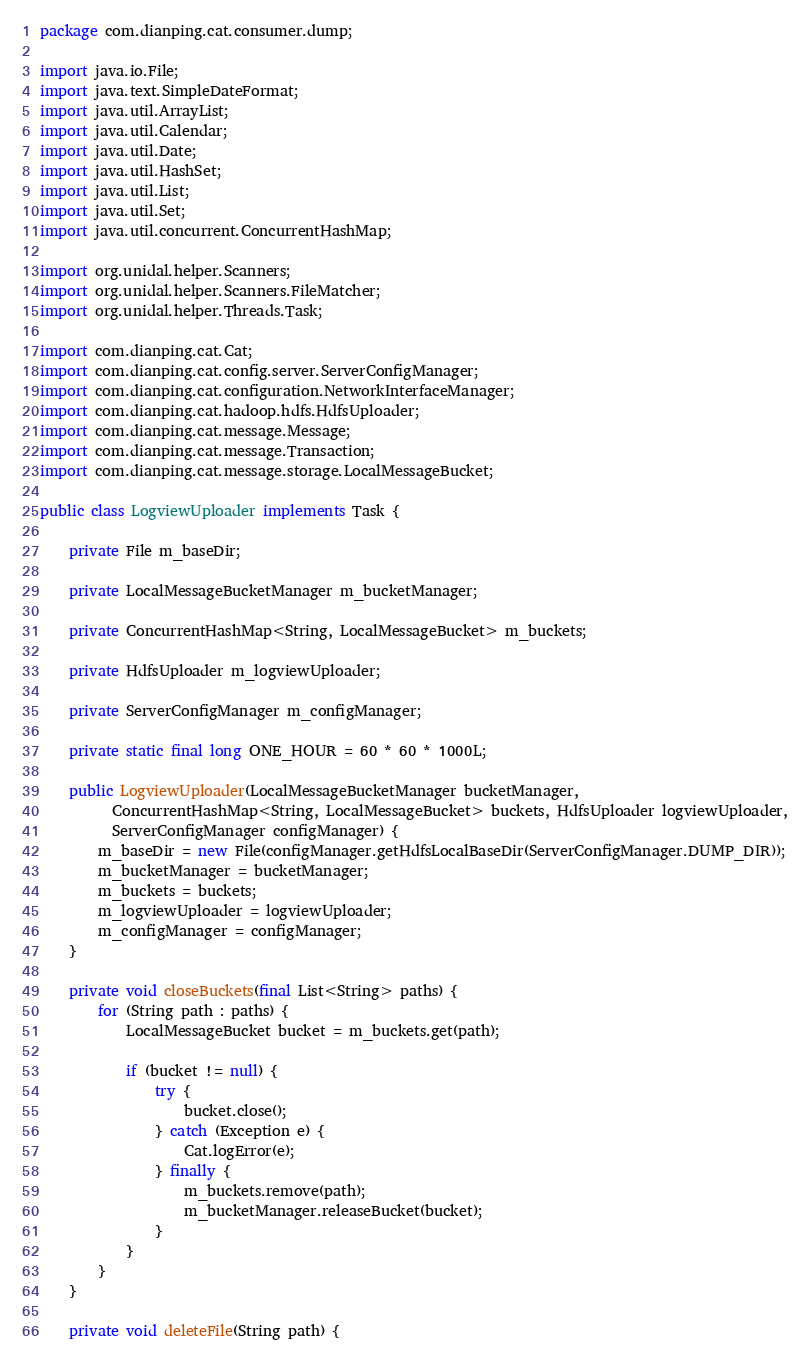<code> <loc_0><loc_0><loc_500><loc_500><_Java_>package com.dianping.cat.consumer.dump;

import java.io.File;
import java.text.SimpleDateFormat;
import java.util.ArrayList;
import java.util.Calendar;
import java.util.Date;
import java.util.HashSet;
import java.util.List;
import java.util.Set;
import java.util.concurrent.ConcurrentHashMap;

import org.unidal.helper.Scanners;
import org.unidal.helper.Scanners.FileMatcher;
import org.unidal.helper.Threads.Task;

import com.dianping.cat.Cat;
import com.dianping.cat.config.server.ServerConfigManager;
import com.dianping.cat.configuration.NetworkInterfaceManager;
import com.dianping.cat.hadoop.hdfs.HdfsUploader;
import com.dianping.cat.message.Message;
import com.dianping.cat.message.Transaction;
import com.dianping.cat.message.storage.LocalMessageBucket;

public class LogviewUploader implements Task {

	private File m_baseDir;

	private LocalMessageBucketManager m_bucketManager;

	private ConcurrentHashMap<String, LocalMessageBucket> m_buckets;

	private HdfsUploader m_logviewUploader;

	private ServerConfigManager m_configManager;

	private static final long ONE_HOUR = 60 * 60 * 1000L;

	public LogviewUploader(LocalMessageBucketManager bucketManager,
	      ConcurrentHashMap<String, LocalMessageBucket> buckets, HdfsUploader logviewUploader,
	      ServerConfigManager configManager) {
		m_baseDir = new File(configManager.getHdfsLocalBaseDir(ServerConfigManager.DUMP_DIR));
		m_bucketManager = bucketManager;
		m_buckets = buckets;
		m_logviewUploader = logviewUploader;
		m_configManager = configManager;
	}

	private void closeBuckets(final List<String> paths) {
		for (String path : paths) {
			LocalMessageBucket bucket = m_buckets.get(path);

			if (bucket != null) {
				try {
					bucket.close();
				} catch (Exception e) {
					Cat.logError(e);
				} finally {
					m_buckets.remove(path);
					m_bucketManager.releaseBucket(bucket);
				}
			}
		}
	}

	private void deleteFile(String path) {</code> 